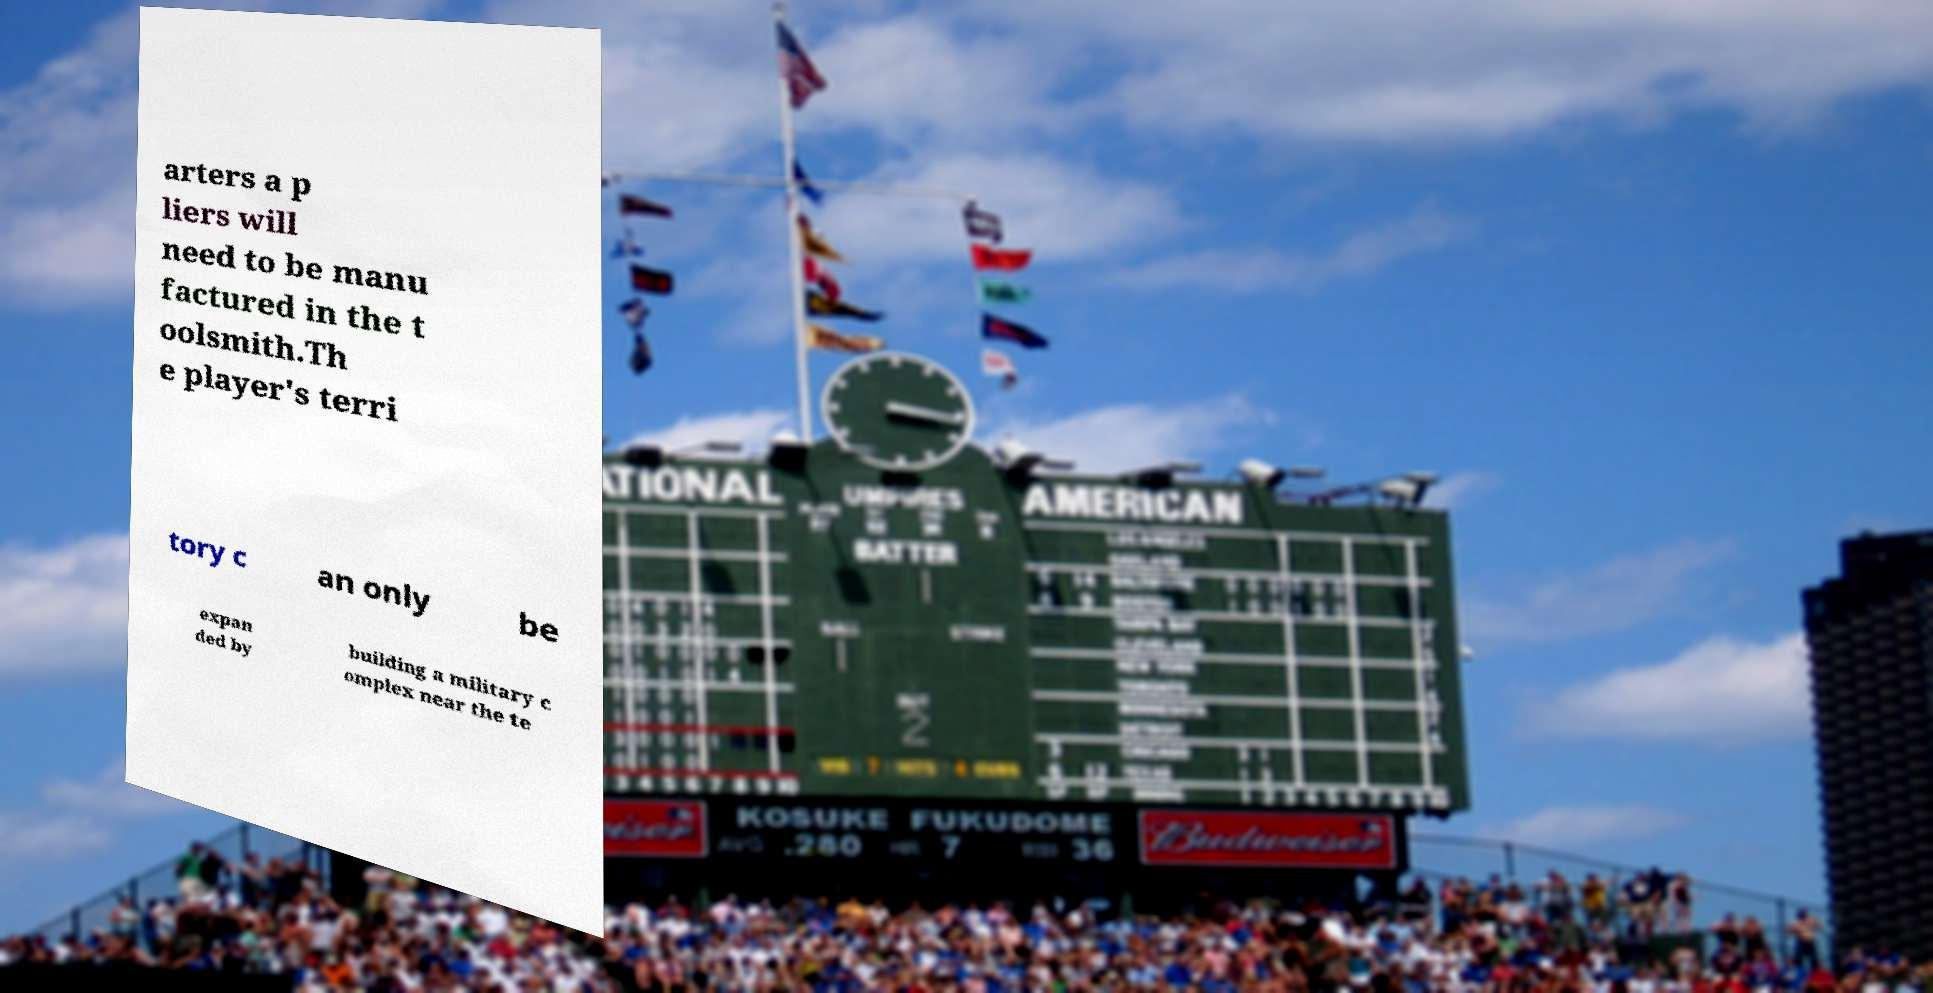Can you accurately transcribe the text from the provided image for me? arters a p liers will need to be manu factured in the t oolsmith.Th e player's terri tory c an only be expan ded by building a military c omplex near the te 